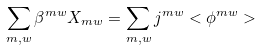<formula> <loc_0><loc_0><loc_500><loc_500>\sum _ { m , w } \beta ^ { m w } X _ { m w } = \sum _ { m , w } j ^ { m w } < \phi ^ { m w } ></formula> 